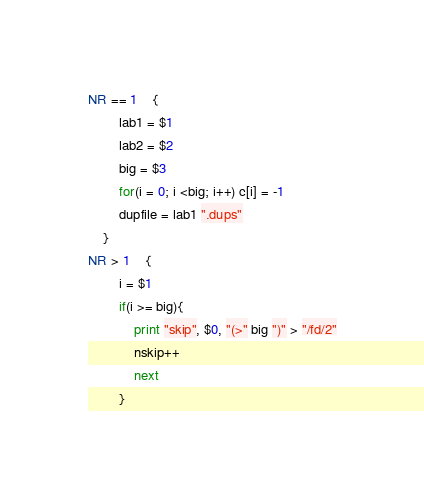Convert code to text. <code><loc_0><loc_0><loc_500><loc_500><_Awk_>NR == 1	{
		lab1 = $1
		lab2 = $2
		big = $3
		for(i = 0; i <big; i++) c[i] = -1
		dupfile = lab1 ".dups"
	}
NR > 1	{
		i = $1
		if(i >= big){
			print "skip", $0, "(>" big ")" > "/fd/2"
			nskip++
			next
		}</code> 